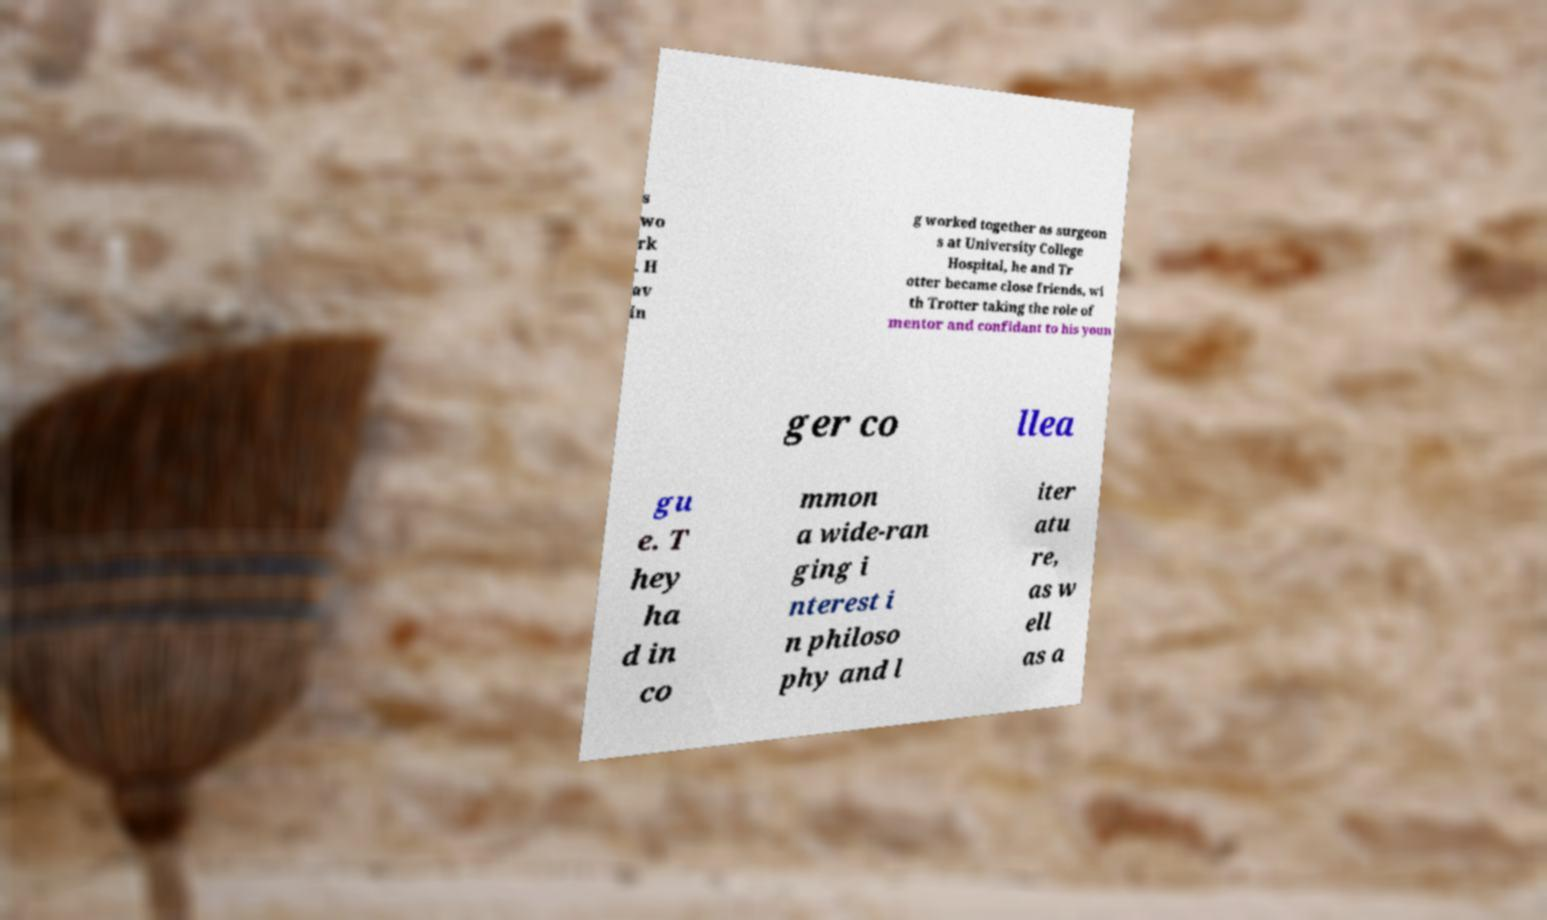There's text embedded in this image that I need extracted. Can you transcribe it verbatim? s wo rk . H av in g worked together as surgeon s at University College Hospital, he and Tr otter became close friends, wi th Trotter taking the role of mentor and confidant to his youn ger co llea gu e. T hey ha d in co mmon a wide-ran ging i nterest i n philoso phy and l iter atu re, as w ell as a 